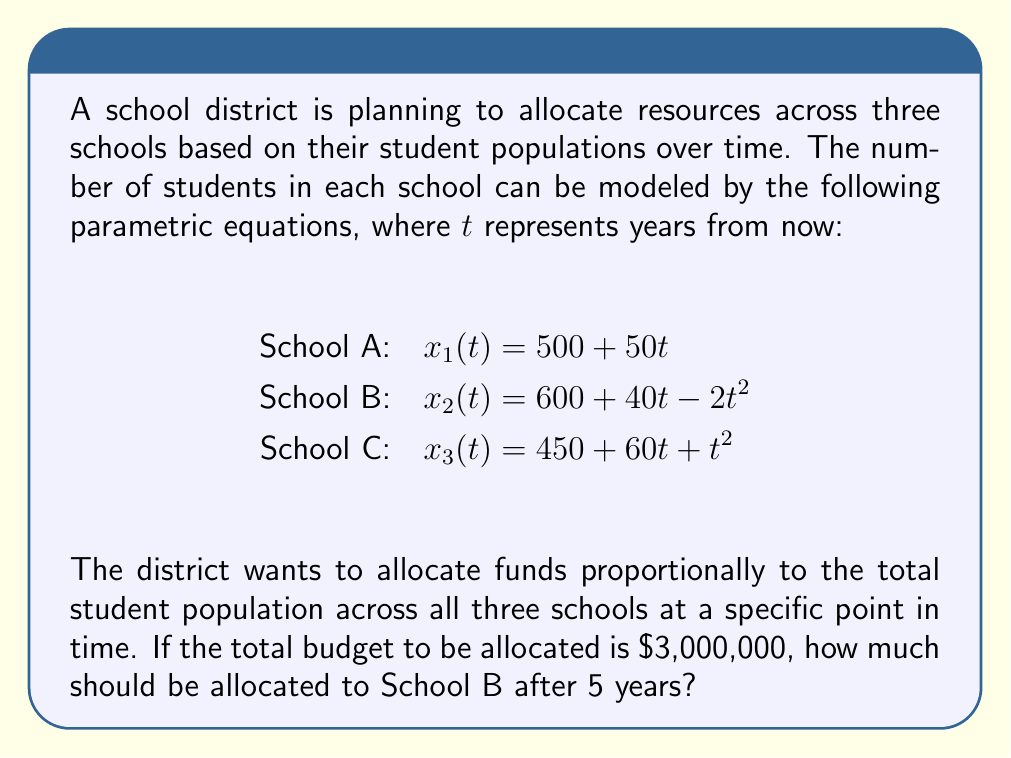Teach me how to tackle this problem. To solve this problem, we need to follow these steps:

1) First, calculate the number of students in each school after 5 years (t = 5):

   School A: $x_1(5) = 500 + 50(5) = 750$ students
   School B: $x_2(5) = 600 + 40(5) - 2(5)^2 = 600 + 200 - 50 = 750$ students
   School C: $x_3(5) = 450 + 60(5) + (5)^2 = 450 + 300 + 25 = 775$ students

2) Calculate the total number of students across all schools:

   Total students = 750 + 750 + 775 = 2275

3) Calculate the proportion of students in School B:

   Proportion = $\frac{750}{2275} = \frac{150}{455} \approx 0.3297$

4) Multiply the total budget by this proportion to get School B's allocation:

   School B allocation = $3,000,000 \times \frac{150}{455} = \$989,010.99$

Therefore, after 5 years, School B should be allocated approximately $989,011 from the total budget.
Answer: $989,011 